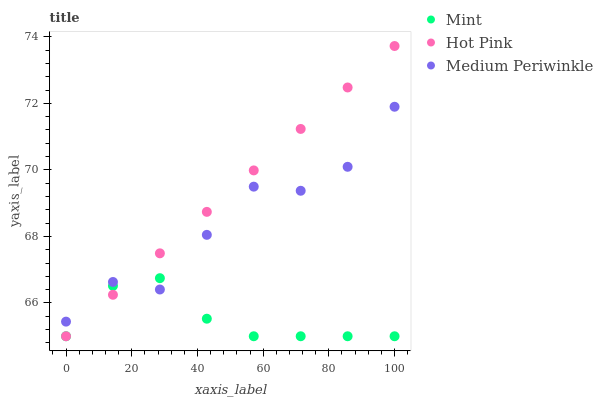Does Mint have the minimum area under the curve?
Answer yes or no. Yes. Does Hot Pink have the maximum area under the curve?
Answer yes or no. Yes. Does Hot Pink have the minimum area under the curve?
Answer yes or no. No. Does Mint have the maximum area under the curve?
Answer yes or no. No. Is Hot Pink the smoothest?
Answer yes or no. Yes. Is Medium Periwinkle the roughest?
Answer yes or no. Yes. Is Mint the smoothest?
Answer yes or no. No. Is Mint the roughest?
Answer yes or no. No. Does Hot Pink have the lowest value?
Answer yes or no. Yes. Does Hot Pink have the highest value?
Answer yes or no. Yes. Does Mint have the highest value?
Answer yes or no. No. Does Mint intersect Medium Periwinkle?
Answer yes or no. Yes. Is Mint less than Medium Periwinkle?
Answer yes or no. No. Is Mint greater than Medium Periwinkle?
Answer yes or no. No. 